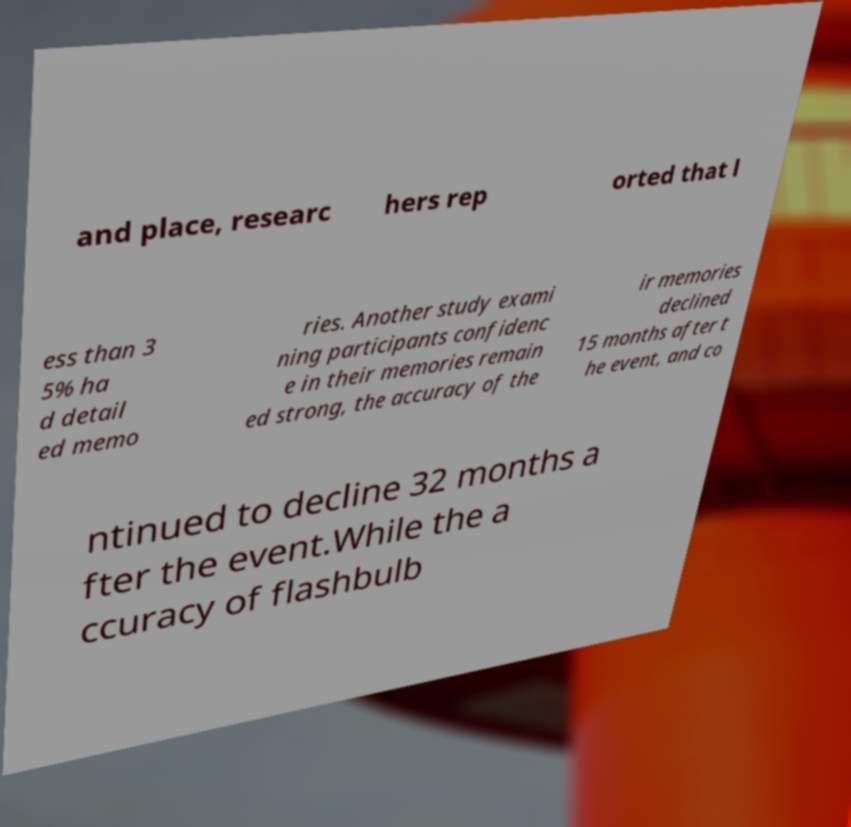Could you assist in decoding the text presented in this image and type it out clearly? and place, researc hers rep orted that l ess than 3 5% ha d detail ed memo ries. Another study exami ning participants confidenc e in their memories remain ed strong, the accuracy of the ir memories declined 15 months after t he event, and co ntinued to decline 32 months a fter the event.While the a ccuracy of flashbulb 